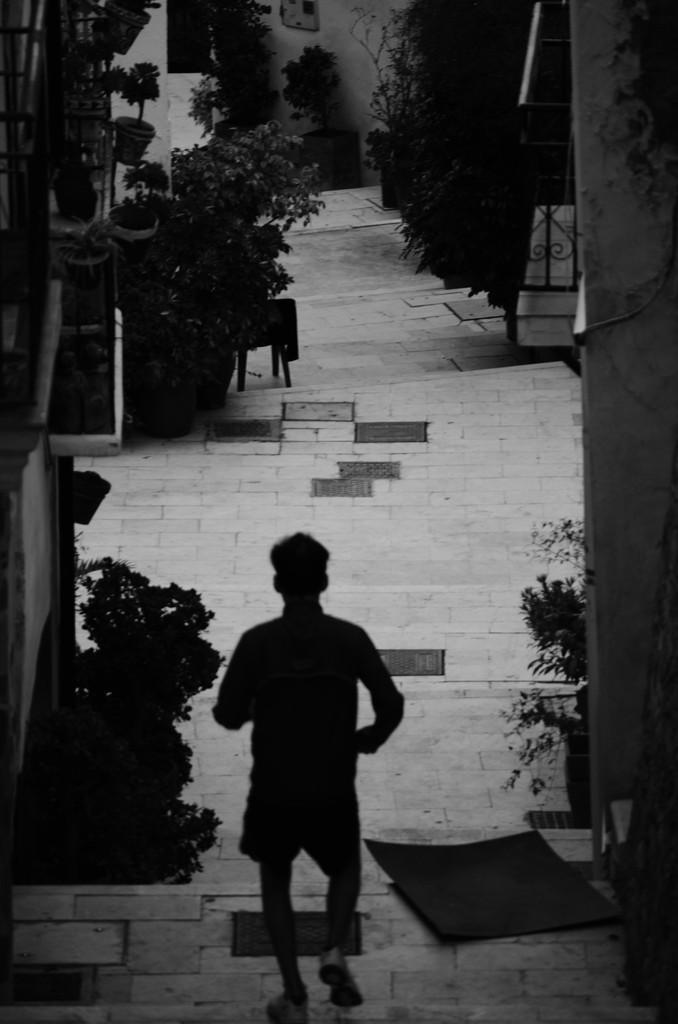Describe this image in one or two sentences. In this image a person is walking on the street. On both sides there are plants, trees, buildings. 